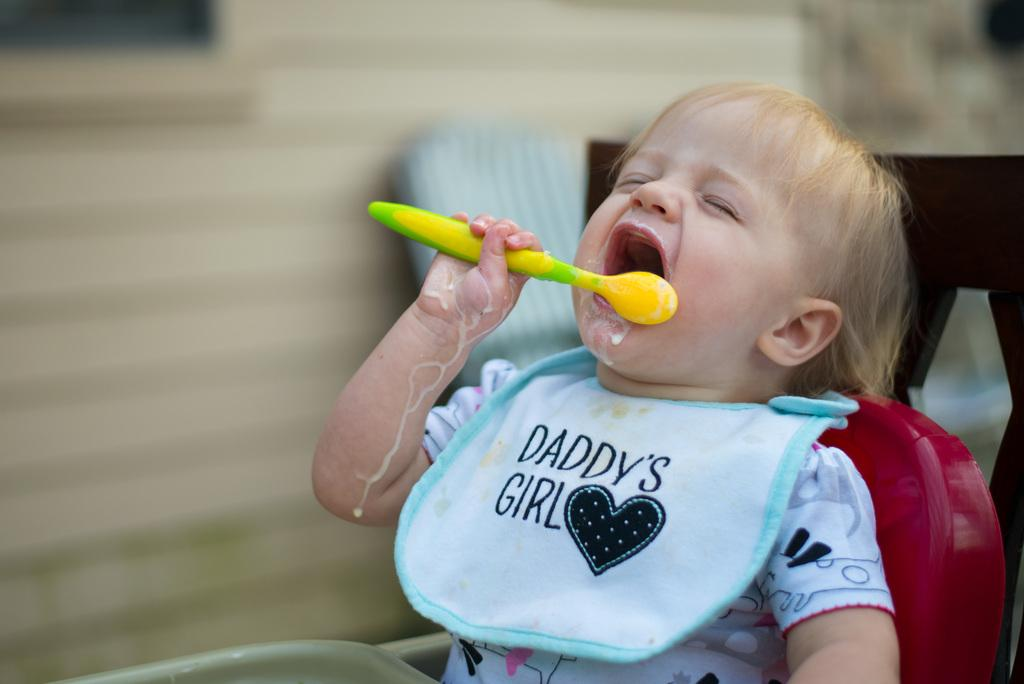What is the main subject of the image? There is a baby in the image. What is the baby doing in the image? The baby is sitting in the image. What object is the baby holding? The baby is holding a spoon in the image. What can be seen in the background of the image? There is a wall in the background of the image. What type of learning is the baby participating in during the trip in the image? There is no trip or learning activity depicted in the image; it simply shows a baby sitting and holding a spoon. 